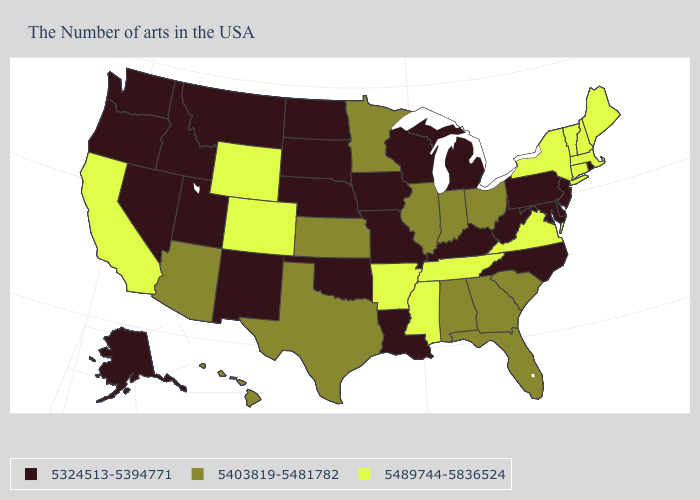Among the states that border Alabama , which have the highest value?
Short answer required. Tennessee, Mississippi. Which states have the highest value in the USA?
Give a very brief answer. Maine, Massachusetts, New Hampshire, Vermont, Connecticut, New York, Virginia, Tennessee, Mississippi, Arkansas, Wyoming, Colorado, California. What is the value of New Jersey?
Short answer required. 5324513-5394771. Does Rhode Island have the same value as Pennsylvania?
Write a very short answer. Yes. Among the states that border Massachusetts , does Rhode Island have the lowest value?
Answer briefly. Yes. What is the value of Virginia?
Give a very brief answer. 5489744-5836524. Name the states that have a value in the range 5324513-5394771?
Write a very short answer. Rhode Island, New Jersey, Delaware, Maryland, Pennsylvania, North Carolina, West Virginia, Michigan, Kentucky, Wisconsin, Louisiana, Missouri, Iowa, Nebraska, Oklahoma, South Dakota, North Dakota, New Mexico, Utah, Montana, Idaho, Nevada, Washington, Oregon, Alaska. Among the states that border Iowa , does South Dakota have the highest value?
Short answer required. No. Name the states that have a value in the range 5324513-5394771?
Write a very short answer. Rhode Island, New Jersey, Delaware, Maryland, Pennsylvania, North Carolina, West Virginia, Michigan, Kentucky, Wisconsin, Louisiana, Missouri, Iowa, Nebraska, Oklahoma, South Dakota, North Dakota, New Mexico, Utah, Montana, Idaho, Nevada, Washington, Oregon, Alaska. Does the first symbol in the legend represent the smallest category?
Give a very brief answer. Yes. Which states have the lowest value in the Northeast?
Quick response, please. Rhode Island, New Jersey, Pennsylvania. Name the states that have a value in the range 5489744-5836524?
Concise answer only. Maine, Massachusetts, New Hampshire, Vermont, Connecticut, New York, Virginia, Tennessee, Mississippi, Arkansas, Wyoming, Colorado, California. Which states have the lowest value in the USA?
Quick response, please. Rhode Island, New Jersey, Delaware, Maryland, Pennsylvania, North Carolina, West Virginia, Michigan, Kentucky, Wisconsin, Louisiana, Missouri, Iowa, Nebraska, Oklahoma, South Dakota, North Dakota, New Mexico, Utah, Montana, Idaho, Nevada, Washington, Oregon, Alaska. What is the value of Mississippi?
Concise answer only. 5489744-5836524. Does California have the lowest value in the USA?
Write a very short answer. No. 